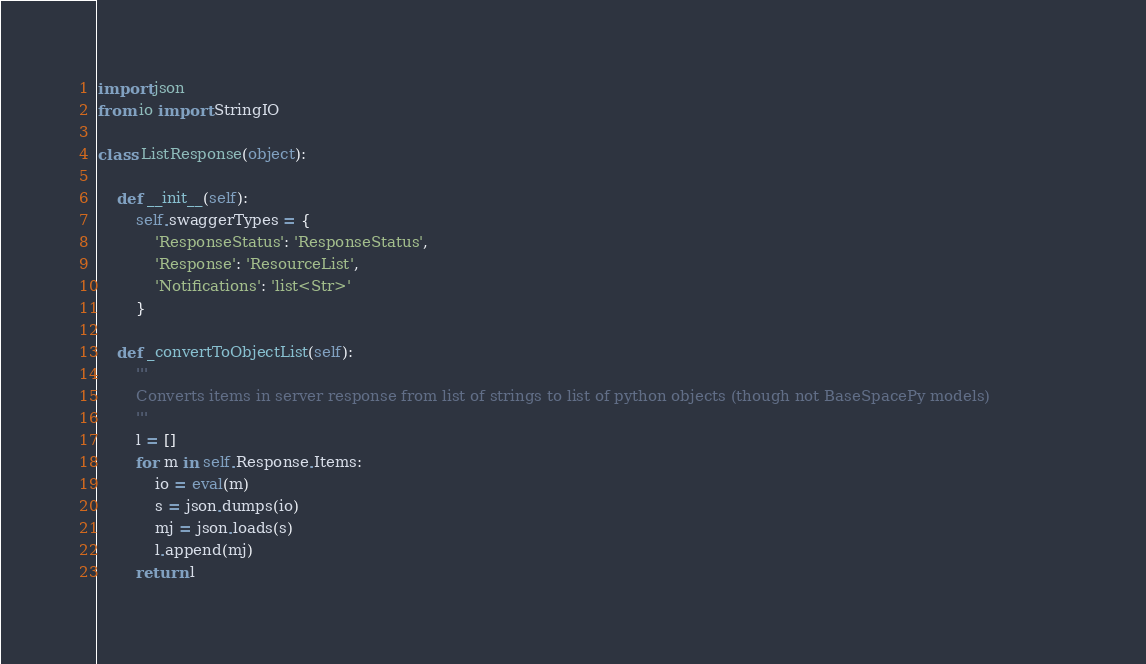Convert code to text. <code><loc_0><loc_0><loc_500><loc_500><_Python_>
import json
from io import StringIO

class ListResponse(object):

    def __init__(self):
        self.swaggerTypes = {
            'ResponseStatus': 'ResponseStatus',
            'Response': 'ResourceList',
            'Notifications': 'list<Str>'
        }

    def _convertToObjectList(self):
        '''
        Converts items in server response from list of strings to list of python objects (though not BaseSpacePy models)                
        '''
        l = []
        for m in self.Response.Items:
            io = eval(m)
            s = json.dumps(io)
            mj = json.loads(s)
            l.append(mj)
        return l
</code> 